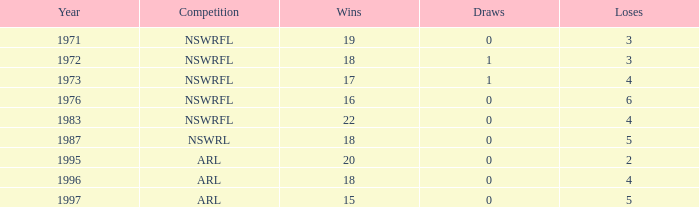With 2 losses and negative draws, what is the average amount of wins? None. Could you help me parse every detail presented in this table? {'header': ['Year', 'Competition', 'Wins', 'Draws', 'Loses'], 'rows': [['1971', 'NSWRFL', '19', '0', '3'], ['1972', 'NSWRFL', '18', '1', '3'], ['1973', 'NSWRFL', '17', '1', '4'], ['1976', 'NSWRFL', '16', '0', '6'], ['1983', 'NSWRFL', '22', '0', '4'], ['1987', 'NSWRL', '18', '0', '5'], ['1995', 'ARL', '20', '0', '2'], ['1996', 'ARL', '18', '0', '4'], ['1997', 'ARL', '15', '0', '5']]} 